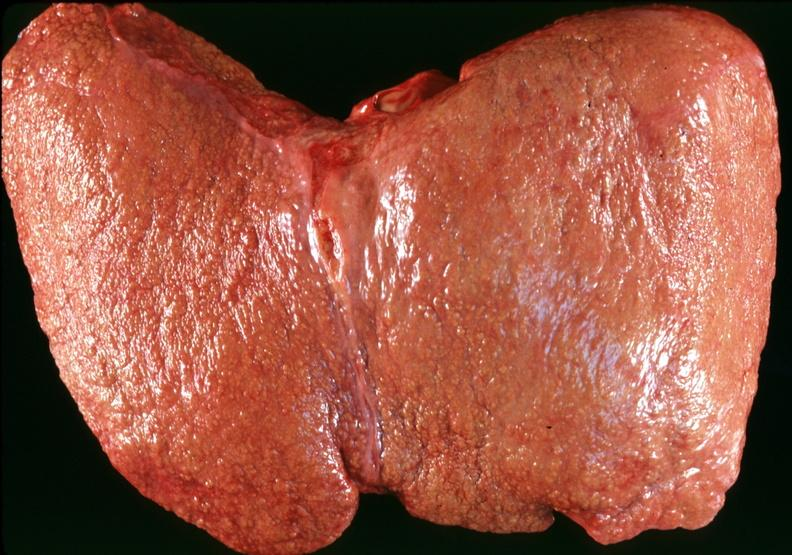s metastatic colon carcinoma present?
Answer the question using a single word or phrase. No 